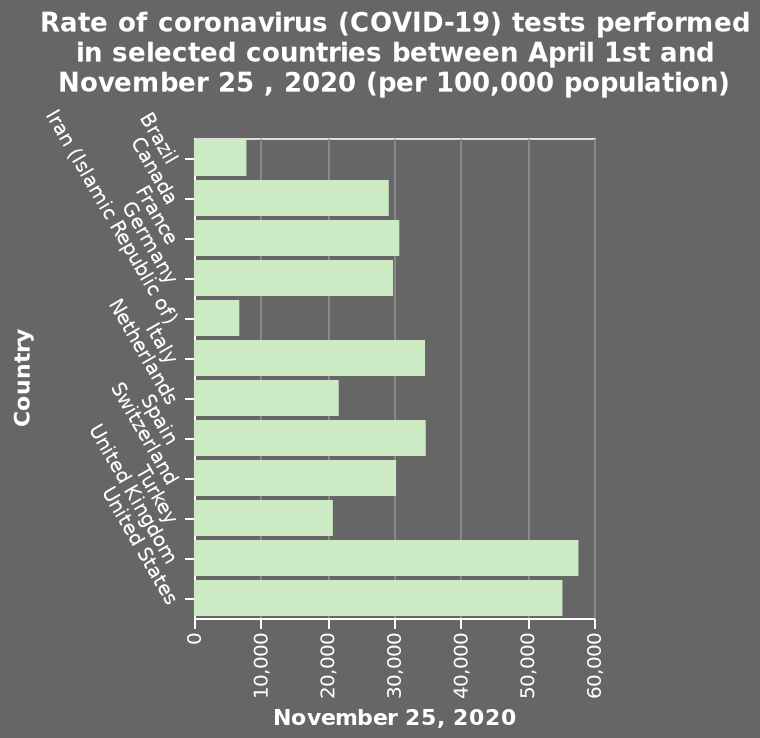<image>
What does the term "per 100,000 population" mean in the figure? The term "per 100,000 population" indicates that the rate of coronavirus tests performed in the selected countries is calculated for every 100,000 individuals in the population. Describe the following image in detail Here a is a bar diagram named Rate of coronavirus (COVID-19) tests performed in selected countries between April 1st and November 25 , 2020 (per 100,000 population). The x-axis plots November 25, 2020 while the y-axis plots Country. How many tests were performed in the United States and United Kingdom?  Over 50,000 tests were performed in the United States and United Kingdom. What is the time period covered by the bar diagram? The bar diagram covers the time period between April 1st and November 25, 2020. please summary the statistics and relations of the chart The United States and United Kingdom were the two highest countries with over 50,000 tests performed. Iran and Brazil are the two lowest countries, with just over 5000 tests carried out. The average tests carried out is approximately 30,000. Which countries had the lowest number of tests carried out?  Iran and Brazil had the lowest number of tests carried out. 